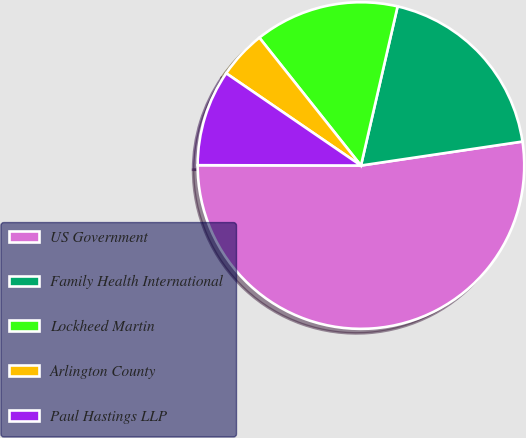Convert chart. <chart><loc_0><loc_0><loc_500><loc_500><pie_chart><fcel>US Government<fcel>Family Health International<fcel>Lockheed Martin<fcel>Arlington County<fcel>Paul Hastings LLP<nl><fcel>52.38%<fcel>19.05%<fcel>14.29%<fcel>4.76%<fcel>9.52%<nl></chart> 